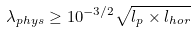<formula> <loc_0><loc_0><loc_500><loc_500>\lambda _ { p h y s } \geq 1 0 ^ { - 3 / 2 } \sqrt { l _ { p } \times l _ { h o r } }</formula> 